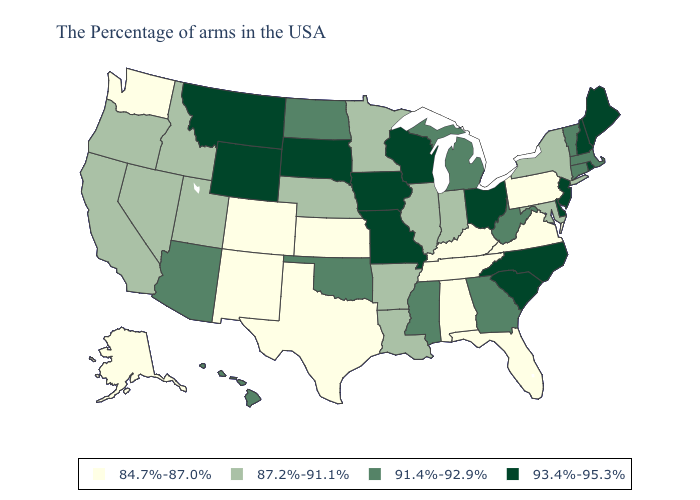What is the value of Louisiana?
Quick response, please. 87.2%-91.1%. What is the value of Connecticut?
Give a very brief answer. 91.4%-92.9%. Among the states that border Michigan , does Indiana have the lowest value?
Short answer required. Yes. What is the lowest value in the MidWest?
Be succinct. 84.7%-87.0%. Does Utah have the highest value in the USA?
Write a very short answer. No. Does the first symbol in the legend represent the smallest category?
Answer briefly. Yes. Among the states that border North Dakota , does Minnesota have the lowest value?
Answer briefly. Yes. What is the lowest value in the MidWest?
Write a very short answer. 84.7%-87.0%. Name the states that have a value in the range 93.4%-95.3%?
Be succinct. Maine, Rhode Island, New Hampshire, New Jersey, Delaware, North Carolina, South Carolina, Ohio, Wisconsin, Missouri, Iowa, South Dakota, Wyoming, Montana. Name the states that have a value in the range 91.4%-92.9%?
Be succinct. Massachusetts, Vermont, Connecticut, West Virginia, Georgia, Michigan, Mississippi, Oklahoma, North Dakota, Arizona, Hawaii. Name the states that have a value in the range 93.4%-95.3%?
Answer briefly. Maine, Rhode Island, New Hampshire, New Jersey, Delaware, North Carolina, South Carolina, Ohio, Wisconsin, Missouri, Iowa, South Dakota, Wyoming, Montana. Name the states that have a value in the range 87.2%-91.1%?
Keep it brief. New York, Maryland, Indiana, Illinois, Louisiana, Arkansas, Minnesota, Nebraska, Utah, Idaho, Nevada, California, Oregon. Which states have the lowest value in the USA?
Write a very short answer. Pennsylvania, Virginia, Florida, Kentucky, Alabama, Tennessee, Kansas, Texas, Colorado, New Mexico, Washington, Alaska. Name the states that have a value in the range 91.4%-92.9%?
Be succinct. Massachusetts, Vermont, Connecticut, West Virginia, Georgia, Michigan, Mississippi, Oklahoma, North Dakota, Arizona, Hawaii. What is the highest value in the USA?
Quick response, please. 93.4%-95.3%. 